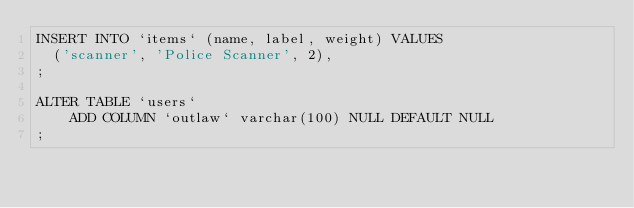Convert code to text. <code><loc_0><loc_0><loc_500><loc_500><_SQL_>INSERT INTO `items` (name, label, weight) VALUES
	('scanner', 'Police Scanner', 2),
;

ALTER TABLE `users`
    ADD COLUMN `outlaw` varchar(100) NULL DEFAULT NULL
;
</code> 